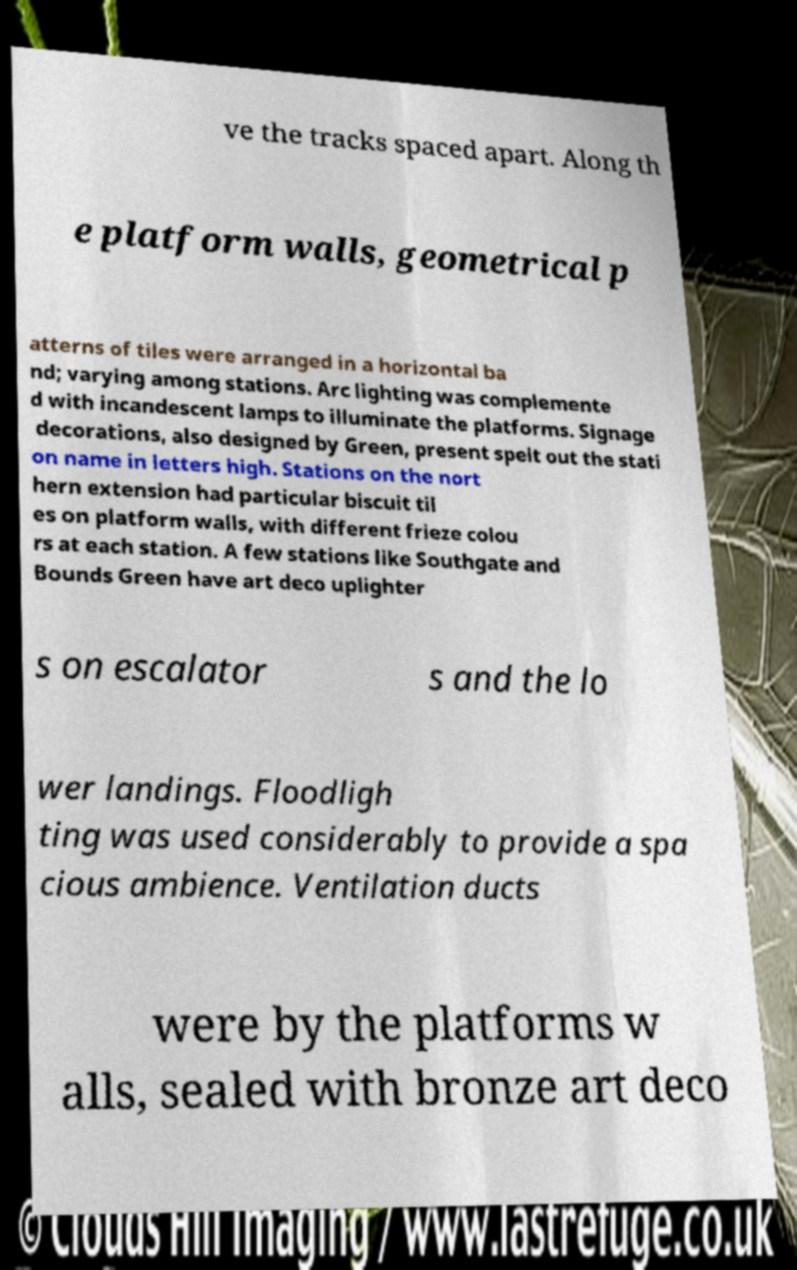Please read and relay the text visible in this image. What does it say? ve the tracks spaced apart. Along th e platform walls, geometrical p atterns of tiles were arranged in a horizontal ba nd; varying among stations. Arc lighting was complemente d with incandescent lamps to illuminate the platforms. Signage decorations, also designed by Green, present spelt out the stati on name in letters high. Stations on the nort hern extension had particular biscuit til es on platform walls, with different frieze colou rs at each station. A few stations like Southgate and Bounds Green have art deco uplighter s on escalator s and the lo wer landings. Floodligh ting was used considerably to provide a spa cious ambience. Ventilation ducts were by the platforms w alls, sealed with bronze art deco 